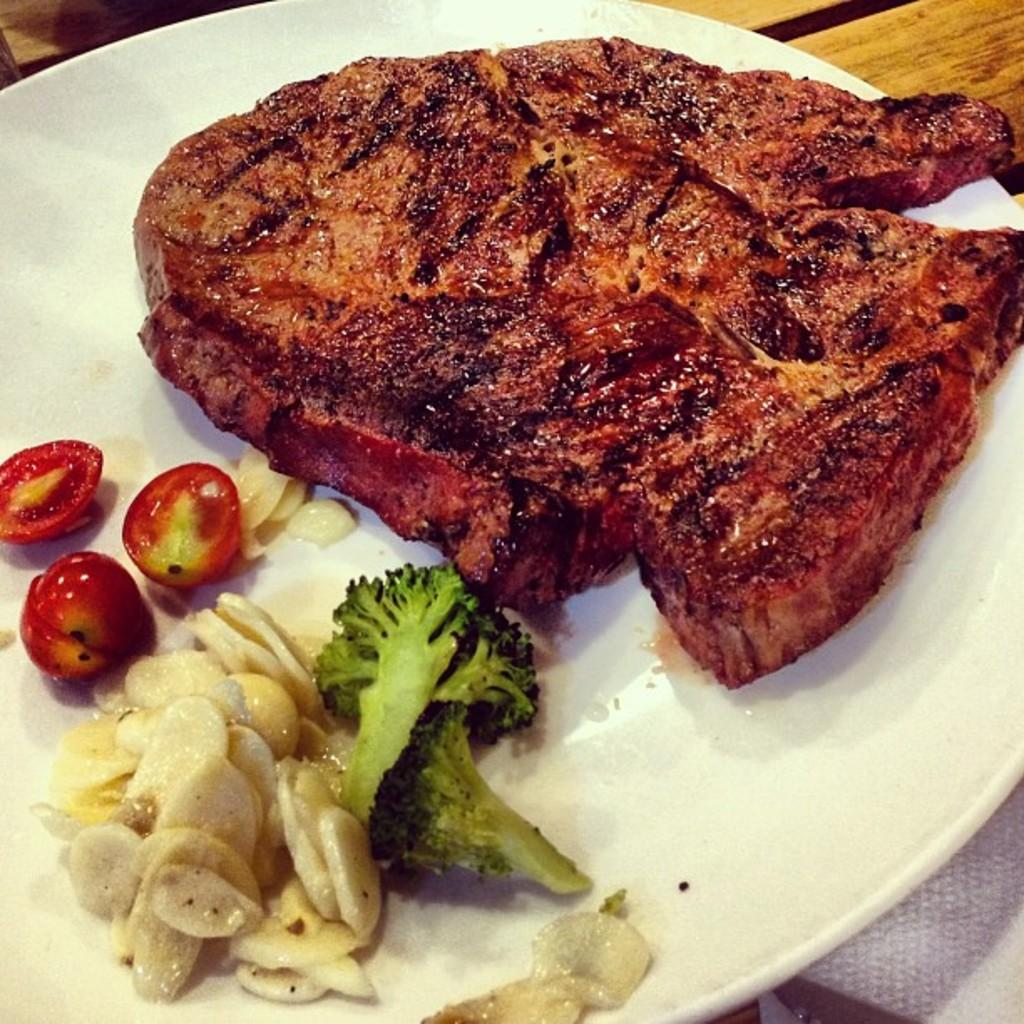What is on the plate that is visible in the image? There are tomatoes, broccoli, and meat on the plate. What color is the plate in the image? The plate is white. Can you describe the contents of the plate in more detail? The plate contains tomatoes, broccoli, and meat. How does hope increase the size of the tomatoes on the plate? Hope is not a tangible object and cannot physically affect the size of the tomatoes on the plate. The tomatoes' size is determined by factors such as growing conditions and variety, not hope. 